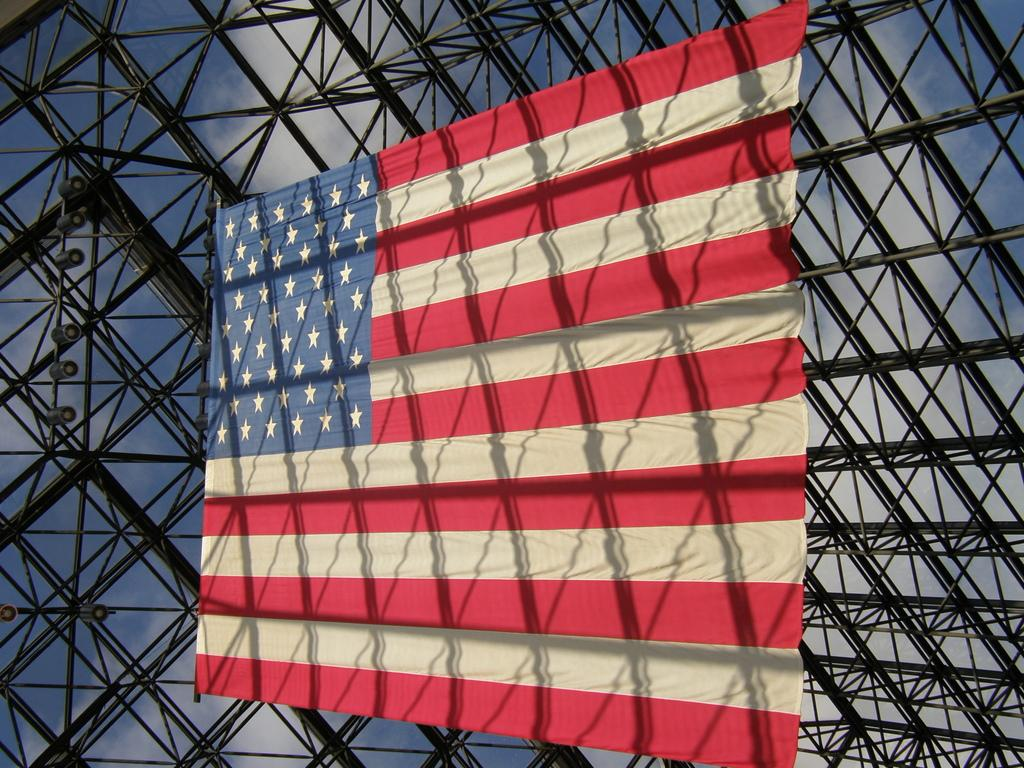What is present in the image that represents a symbol or country? There is a flag in the image. Where is the flag located? The flag is on a metal fence. What can be seen in the image that provides illumination? There are lights visible in the image. How would you describe the weather based on the image? The sky is cloudy in the image. What is the limit of the office space in the image? There is no office space present in the image, so it is not possible to determine a limit. 